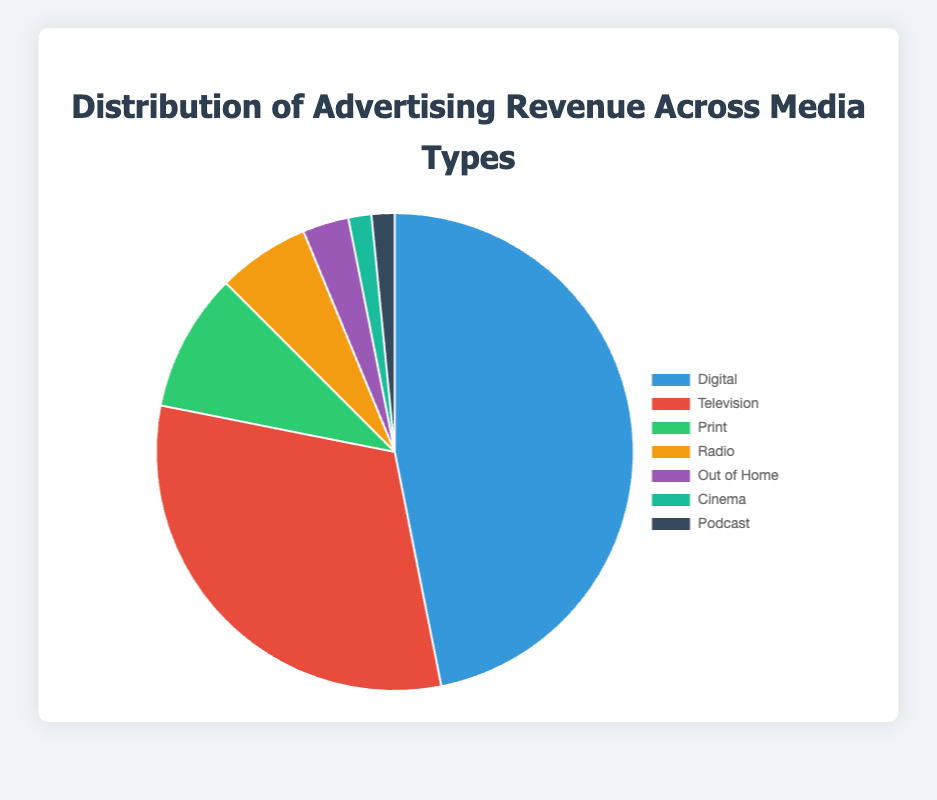What percentage of the total advertising revenue does Digital media account for? The total advertising revenue is $150,000,000 (Digital) + $100,000,000 (Television) + $30,000,000 (Print) + $20,000,000 (Radio) + $10,000,000 (Out of Home) + $5,000,000 (Cinema) + $5,000,000 (Podcast) = $320,000,000. The percentage for Digital media is ($150,000,000 / $320,000,000) * 100% ≈ 46.88%
Answer: 46.88% Which media type has the second-largest share of the advertising revenue? Based on the pie chart, after Digital ($150,000,000), Television has the next largest share with $100,000,000.
Answer: Television What is the combined revenue of Radio and Print media? Radio's revenue is $20,000,000, and Print's revenue is $30,000,000. The combined revenue is $20,000,000 + $30,000,000 = $50,000,000.
Answer: $50,000,000 How does the revenue from Cinema compare to that from Podcast? Both Cinema and Podcast media generate the same revenue, which is $5,000,000.
Answer: Equal What is the difference in advertising revenue between Digital and Print media? Digital media's revenue is $150,000,000 and Print media's revenue is $30,000,000. The difference is $150,000,000 - $30,000,000 = $120,000,000.
Answer: $120,000,000 What percentage of the total revenue comes from "Out of Home" and "Cinema" combined? The combined revenue from "Out of Home" and "Cinema" is $10,000,000 + $5,000,000 = $15,000,000. The total advertising revenue is $320,000,000. The percentage is ($15,000,000 / $320,000,000) * 100% ≈ 4.69%.
Answer: 4.69% Which media type has the lowest advertising revenue, and how much is it? Both Cinema and Podcast media have the lowest advertising revenue, each generating $5,000,000.
Answer: Cinema and Podcast, $5,000,000 How does the revenue from Television compare to the combined revenue from Print and Radio? Television has $100,000,000 in advertising revenue. The combined revenue from Print and Radio is $30,000,000 + $20,000,000 = $50,000,000, which is half of Television's revenue.
Answer: Television's revenue is double that of combined Print and Radio Calculate the total revenue from non-digital media types Summing up non-digital media revenues: $100,000,000 (Television) + $30,000,000 (Print) + $20,000,000 (Radio) + $10,000,000 (Out of Home) + $5,000,000 (Cinema) + $5,000,000 (Podcast) = $170,000,000.
Answer: $170,000,000 What is the ratio of the revenue from Television to that from Digital? The revenue from Television is $100,000,000, and from Digital, it is $150,000,000. The ratio is $100,000,000 / $150,000,000 = 2:3.
Answer: 2:3 